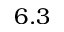<formula> <loc_0><loc_0><loc_500><loc_500>6 . 3</formula> 